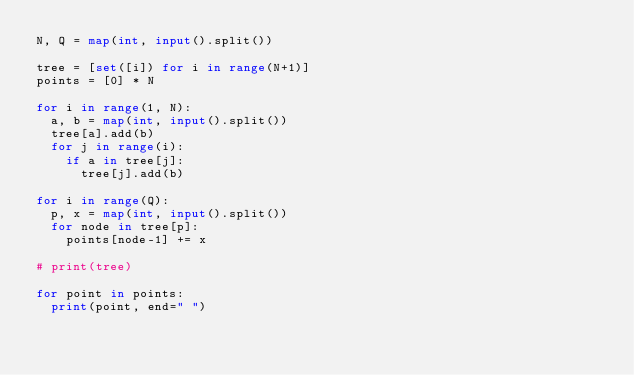Convert code to text. <code><loc_0><loc_0><loc_500><loc_500><_Python_>N, Q = map(int, input().split())

tree = [set([i]) for i in range(N+1)]
points = [0] * N

for i in range(1, N):
  a, b = map(int, input().split())
  tree[a].add(b)
  for j in range(i):
    if a in tree[j]:
      tree[j].add(b)
      
for i in range(Q):
  p, x = map(int, input().split())
  for node in tree[p]:
    points[node-1] += x

# print(tree)
    
for point in points:
  print(point, end=" ")</code> 